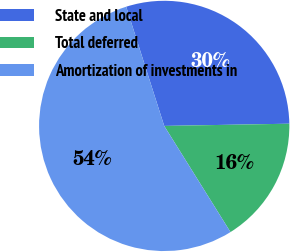<chart> <loc_0><loc_0><loc_500><loc_500><pie_chart><fcel>State and local<fcel>Total deferred<fcel>Amortization of investments in<nl><fcel>29.63%<fcel>16.4%<fcel>53.97%<nl></chart> 